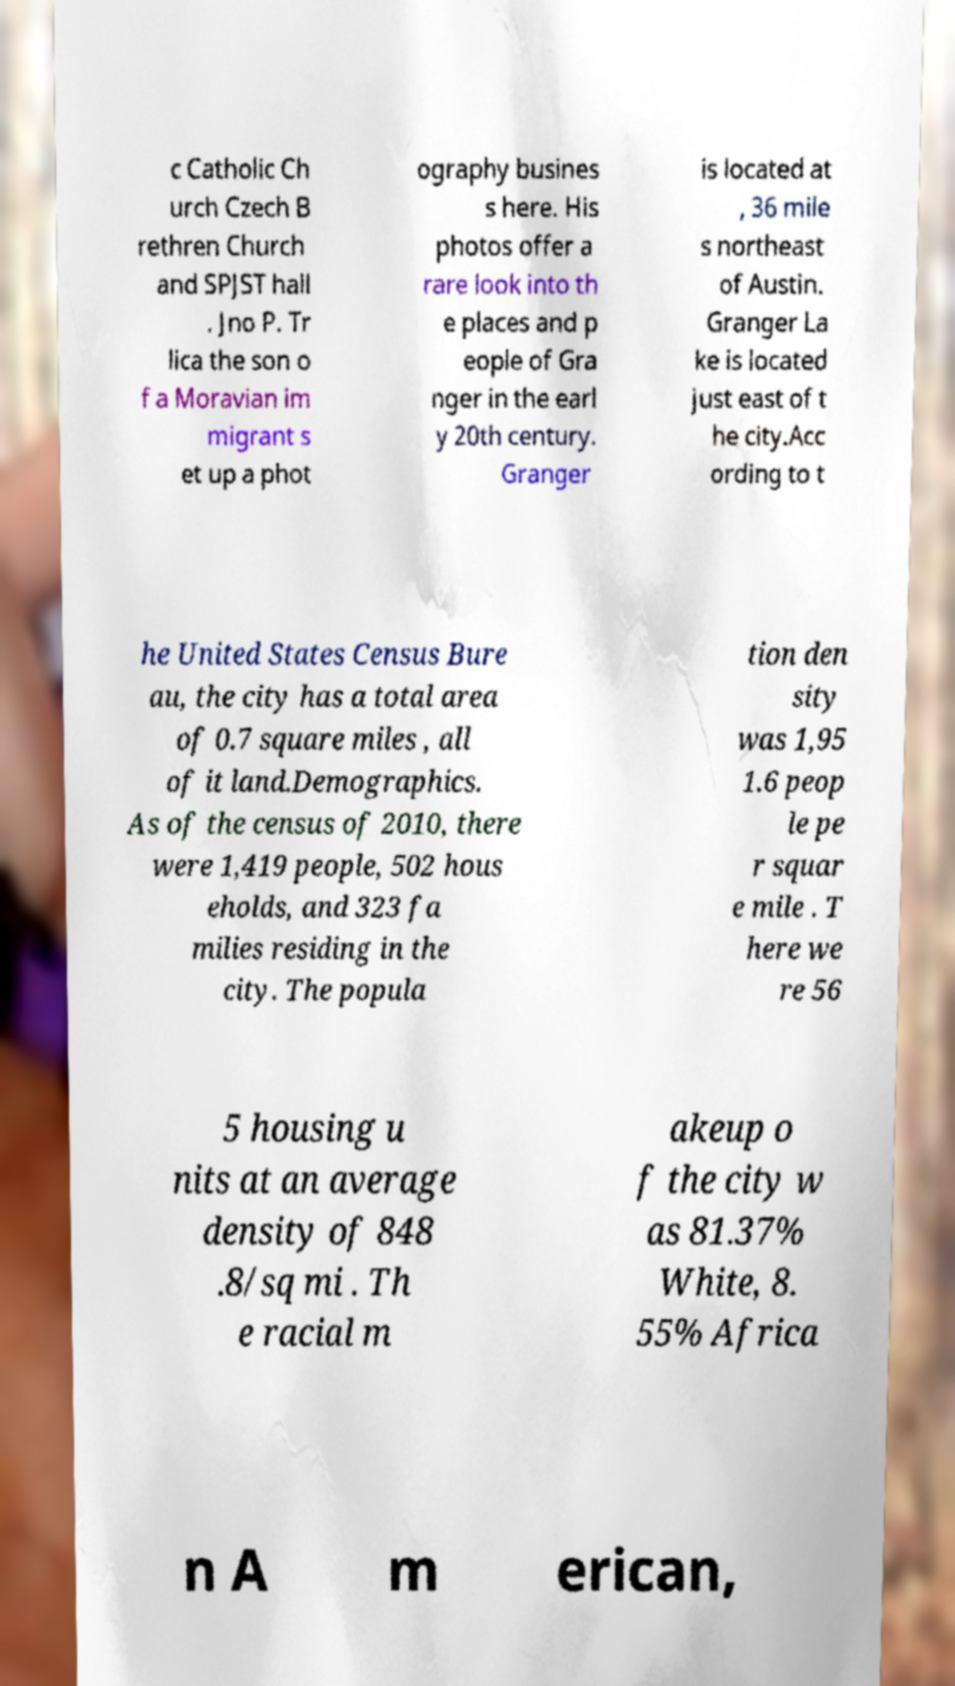Please identify and transcribe the text found in this image. c Catholic Ch urch Czech B rethren Church and SPJST hall . Jno P. Tr lica the son o f a Moravian im migrant s et up a phot ography busines s here. His photos offer a rare look into th e places and p eople of Gra nger in the earl y 20th century. Granger is located at , 36 mile s northeast of Austin. Granger La ke is located just east of t he city.Acc ording to t he United States Census Bure au, the city has a total area of 0.7 square miles , all of it land.Demographics. As of the census of 2010, there were 1,419 people, 502 hous eholds, and 323 fa milies residing in the city. The popula tion den sity was 1,95 1.6 peop le pe r squar e mile . T here we re 56 5 housing u nits at an average density of 848 .8/sq mi . Th e racial m akeup o f the city w as 81.37% White, 8. 55% Africa n A m erican, 